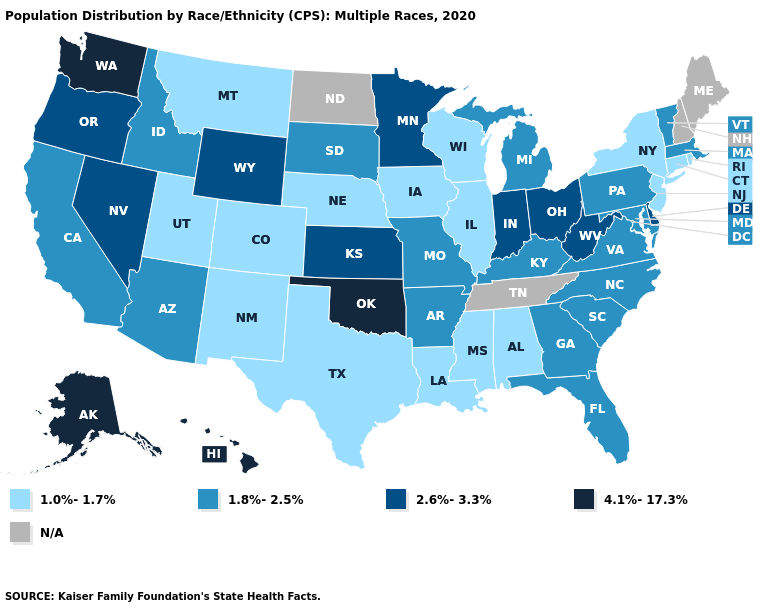Name the states that have a value in the range 4.1%-17.3%?
Keep it brief. Alaska, Hawaii, Oklahoma, Washington. Does the first symbol in the legend represent the smallest category?
Concise answer only. Yes. What is the lowest value in the Northeast?
Give a very brief answer. 1.0%-1.7%. Among the states that border Michigan , which have the highest value?
Quick response, please. Indiana, Ohio. What is the value of Pennsylvania?
Be succinct. 1.8%-2.5%. Does California have the lowest value in the USA?
Concise answer only. No. What is the value of Wisconsin?
Keep it brief. 1.0%-1.7%. What is the value of Connecticut?
Write a very short answer. 1.0%-1.7%. Does the map have missing data?
Concise answer only. Yes. Does New Jersey have the lowest value in the USA?
Be succinct. Yes. Does South Carolina have the lowest value in the USA?
Give a very brief answer. No. How many symbols are there in the legend?
Give a very brief answer. 5. Name the states that have a value in the range 2.6%-3.3%?
Quick response, please. Delaware, Indiana, Kansas, Minnesota, Nevada, Ohio, Oregon, West Virginia, Wyoming. Does Georgia have the lowest value in the South?
Keep it brief. No. 